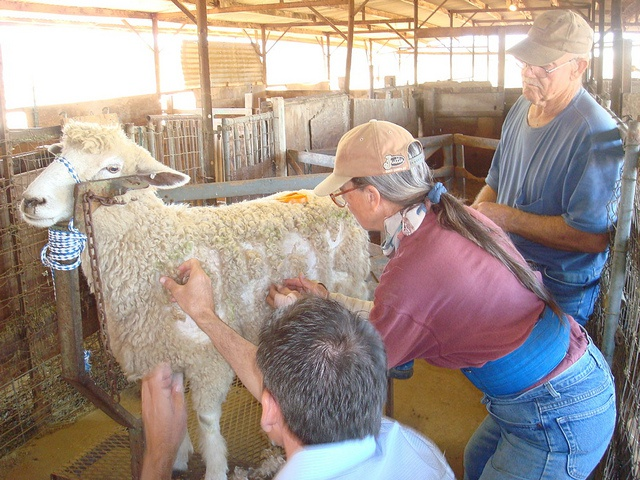Describe the objects in this image and their specific colors. I can see people in tan, brown, lightpink, gray, and lightblue tones, sheep in tan, darkgray, and ivory tones, people in tan, gray, and lightblue tones, people in tan, gray, and darkgray tones, and scissors in tan, orange, khaki, and gold tones in this image. 